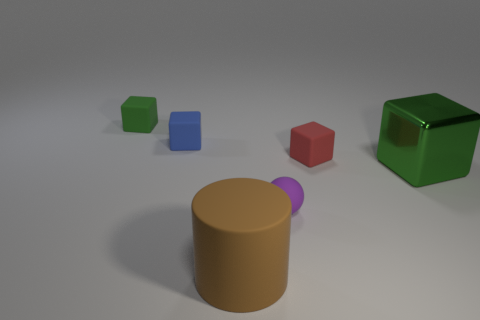Subtract all cyan spheres. Subtract all purple cylinders. How many spheres are left? 1 Add 4 small purple balls. How many objects exist? 10 Subtract all cylinders. How many objects are left? 5 Add 6 tiny blue blocks. How many tiny blue blocks exist? 7 Subtract 0 purple cylinders. How many objects are left? 6 Subtract all tiny yellow matte blocks. Subtract all large matte cylinders. How many objects are left? 5 Add 2 small red rubber cubes. How many small red rubber cubes are left? 3 